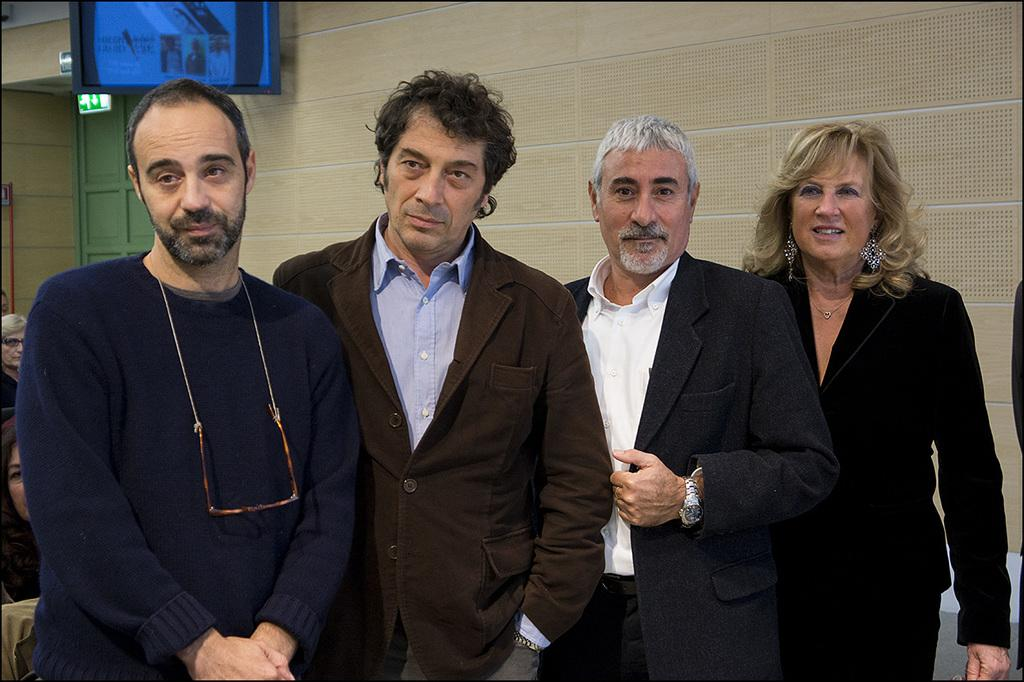How many people are in the image? There are three men and a woman in the image, making a total of four people. What are the people in the image doing? The people are standing in the front and posing for the camera. What can be seen in the background of the image? There is a brown wall and a television screen in the background of the image. What type of popcorn is being served on the television screen in the image? There is no popcorn visible on the television screen in the image. Is there a hammer being used by any of the people in the image? No, there is no hammer present in the image. 